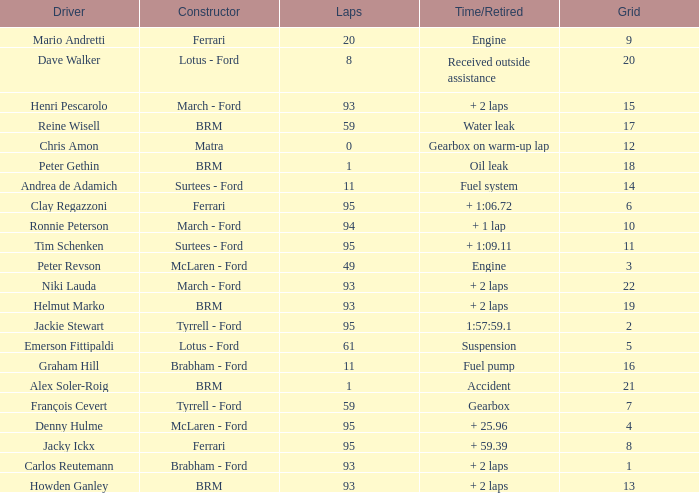What is the largest number of laps with a Grid larger than 14, a Time/Retired of + 2 laps, and a Driver of helmut marko? 93.0. Can you parse all the data within this table? {'header': ['Driver', 'Constructor', 'Laps', 'Time/Retired', 'Grid'], 'rows': [['Mario Andretti', 'Ferrari', '20', 'Engine', '9'], ['Dave Walker', 'Lotus - Ford', '8', 'Received outside assistance', '20'], ['Henri Pescarolo', 'March - Ford', '93', '+ 2 laps', '15'], ['Reine Wisell', 'BRM', '59', 'Water leak', '17'], ['Chris Amon', 'Matra', '0', 'Gearbox on warm-up lap', '12'], ['Peter Gethin', 'BRM', '1', 'Oil leak', '18'], ['Andrea de Adamich', 'Surtees - Ford', '11', 'Fuel system', '14'], ['Clay Regazzoni', 'Ferrari', '95', '+ 1:06.72', '6'], ['Ronnie Peterson', 'March - Ford', '94', '+ 1 lap', '10'], ['Tim Schenken', 'Surtees - Ford', '95', '+ 1:09.11', '11'], ['Peter Revson', 'McLaren - Ford', '49', 'Engine', '3'], ['Niki Lauda', 'March - Ford', '93', '+ 2 laps', '22'], ['Helmut Marko', 'BRM', '93', '+ 2 laps', '19'], ['Jackie Stewart', 'Tyrrell - Ford', '95', '1:57:59.1', '2'], ['Emerson Fittipaldi', 'Lotus - Ford', '61', 'Suspension', '5'], ['Graham Hill', 'Brabham - Ford', '11', 'Fuel pump', '16'], ['Alex Soler-Roig', 'BRM', '1', 'Accident', '21'], ['François Cevert', 'Tyrrell - Ford', '59', 'Gearbox', '7'], ['Denny Hulme', 'McLaren - Ford', '95', '+ 25.96', '4'], ['Jacky Ickx', 'Ferrari', '95', '+ 59.39', '8'], ['Carlos Reutemann', 'Brabham - Ford', '93', '+ 2 laps', '1'], ['Howden Ganley', 'BRM', '93', '+ 2 laps', '13']]} 